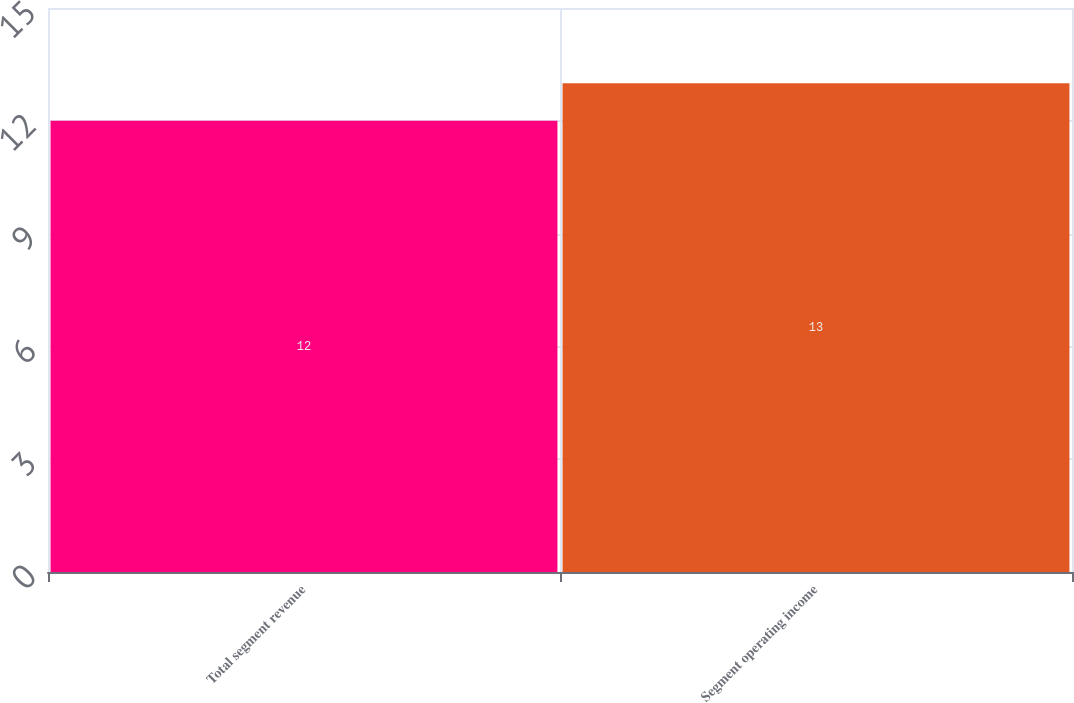Convert chart to OTSL. <chart><loc_0><loc_0><loc_500><loc_500><bar_chart><fcel>Total segment revenue<fcel>Segment operating income<nl><fcel>12<fcel>13<nl></chart> 